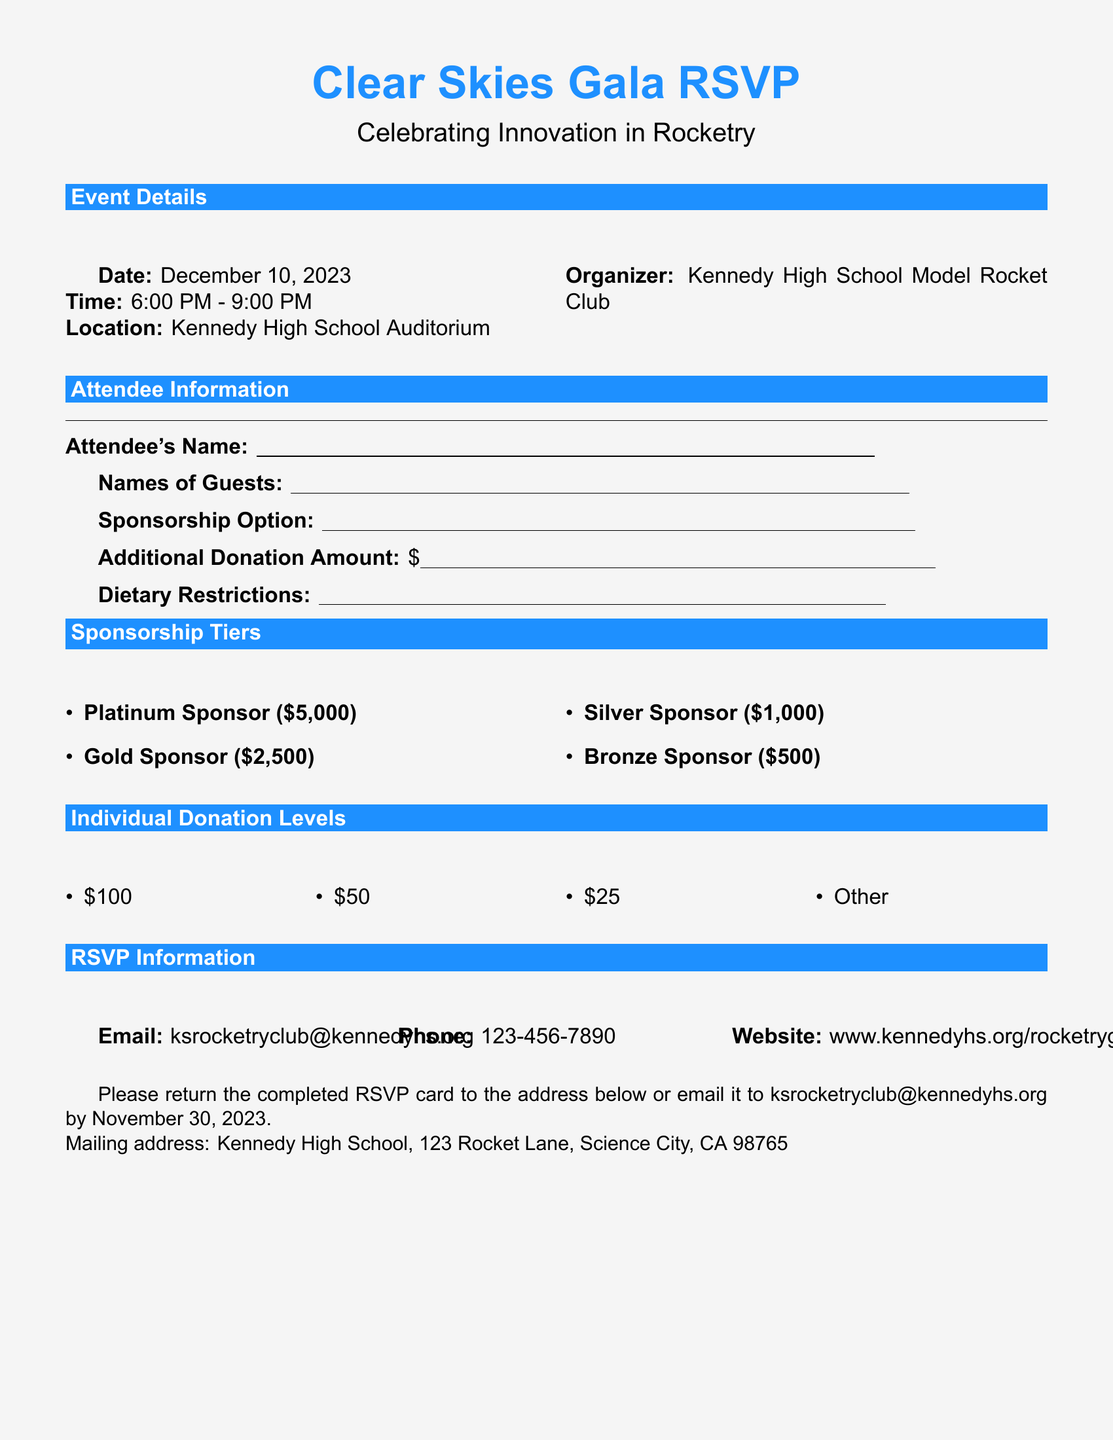what is the date of the gala? The date of the gala is specified in the event details section of the document.
Answer: December 10, 2023 what is the time of the event? The time of the event is provided in the event details section of the document.
Answer: 6:00 PM - 9:00 PM where is the event taking place? The location of the event is mentioned in the event details section of the document.
Answer: Kennedy High School Auditorium who is organizing the event? The organizer of the event is stated in the event details section of the document.
Answer: Kennedy High School Model Rocket Club what is the highest sponsorship tier? The sponsorship tiers section lists all the tiers, including the highest one.
Answer: Platinum Sponsor ($5,000) what is the email address for RSVPs? The RSVP information section provides the email address for returning the completed RSVP card.
Answer: ksrocketryclub@kennedyhs.org what is the deadline for RSVPs? The deadline for RSVPs is mentioned in the last part of the document.
Answer: November 30, 2023 how many sponsorship options are there? The sponsorship tiers section lists all the different sponsorship options.
Answer: Four what are the individual donation levels? The individual donation levels are clearly listed in the document and can be directly referenced.
Answer: $100, $50, $25, Other 